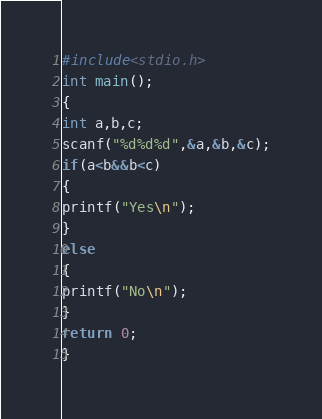<code> <loc_0><loc_0><loc_500><loc_500><_C_>#include<stdio.h>
int main();
{
int a,b,c;
scanf("%d%d%d",&a,&b,&c);
if(a<b&&b<c)
{
printf("Yes\n");
}
else
{
printf("No\n");
}
return 0;
}</code> 